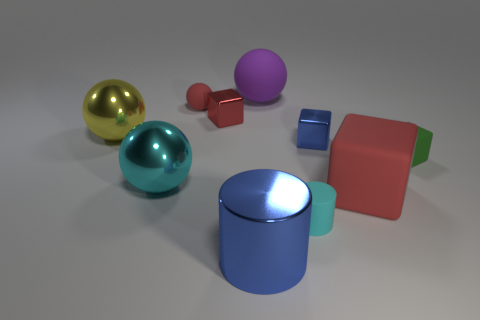Do the purple ball and the green block have the same material?
Your answer should be very brief. Yes. Are there an equal number of tiny red rubber things behind the tiny red sphere and purple rubber things in front of the small cylinder?
Keep it short and to the point. Yes. There is a cyan rubber cylinder right of the big matte thing that is behind the yellow metal sphere; is there a large block that is behind it?
Provide a succinct answer. Yes. Is the size of the cyan cylinder the same as the blue metal cube?
Provide a short and direct response. Yes. What color is the shiny sphere behind the cyan thing on the left side of the big shiny thing that is right of the small red rubber thing?
Keep it short and to the point. Yellow. What number of shiny blocks are the same color as the tiny cylinder?
Make the answer very short. 0. What number of large things are cyan metallic spheres or spheres?
Keep it short and to the point. 3. Is there a large thing that has the same shape as the tiny blue thing?
Offer a terse response. Yes. Is the small green object the same shape as the big red thing?
Your answer should be compact. Yes. What color is the tiny shiny thing that is left of the blue object behind the cyan matte object?
Provide a short and direct response. Red. 